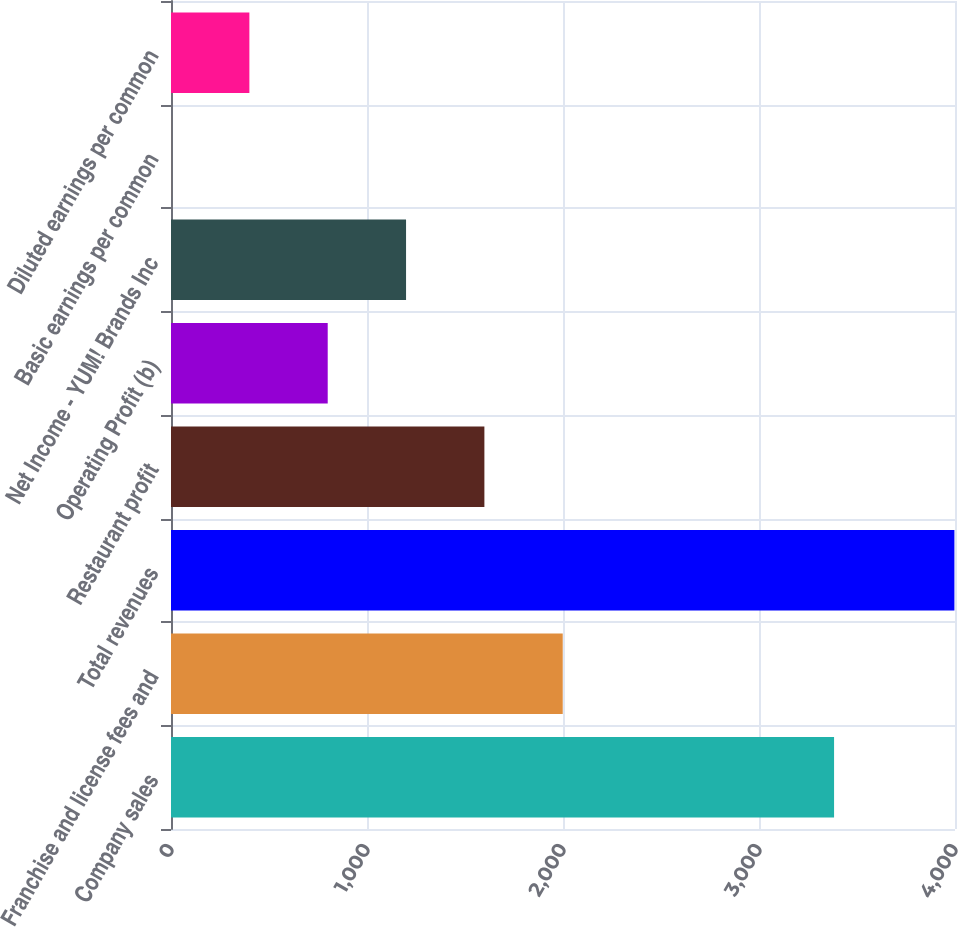Convert chart to OTSL. <chart><loc_0><loc_0><loc_500><loc_500><bar_chart><fcel>Company sales<fcel>Franchise and license fees and<fcel>Total revenues<fcel>Restaurant profit<fcel>Operating Profit (b)<fcel>Net Income - YUM! Brands Inc<fcel>Basic earnings per common<fcel>Diluted earnings per common<nl><fcel>3383<fcel>1998.6<fcel>3997<fcel>1598.92<fcel>799.56<fcel>1199.24<fcel>0.2<fcel>399.88<nl></chart> 